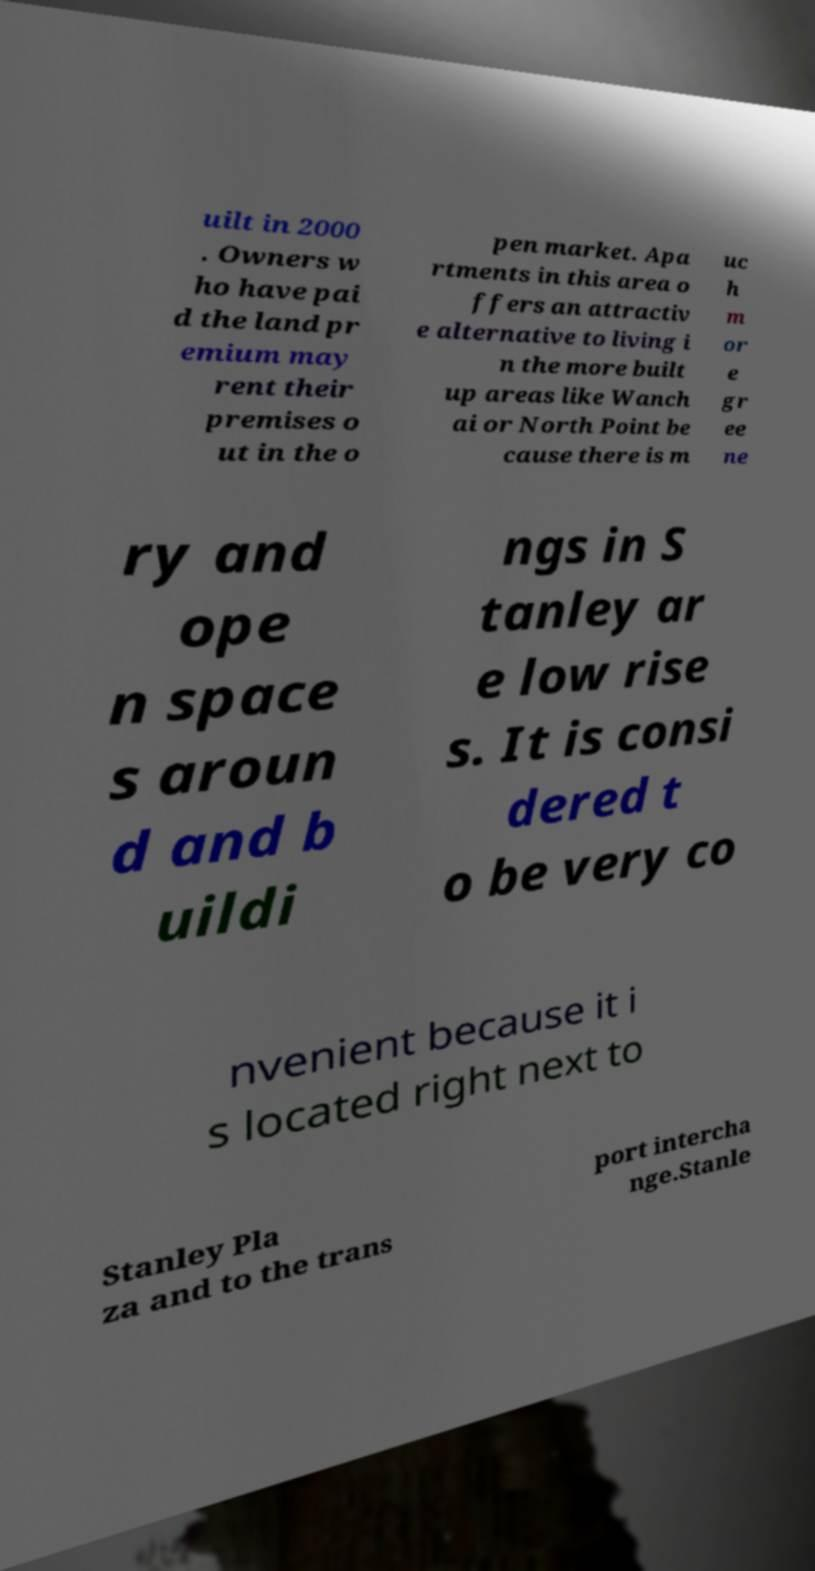There's text embedded in this image that I need extracted. Can you transcribe it verbatim? uilt in 2000 . Owners w ho have pai d the land pr emium may rent their premises o ut in the o pen market. Apa rtments in this area o ffers an attractiv e alternative to living i n the more built up areas like Wanch ai or North Point be cause there is m uc h m or e gr ee ne ry and ope n space s aroun d and b uildi ngs in S tanley ar e low rise s. It is consi dered t o be very co nvenient because it i s located right next to Stanley Pla za and to the trans port intercha nge.Stanle 